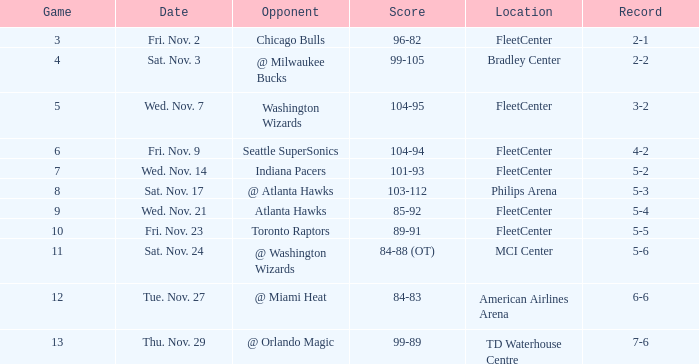What is the earliest game with a score of 99-89? 13.0. 